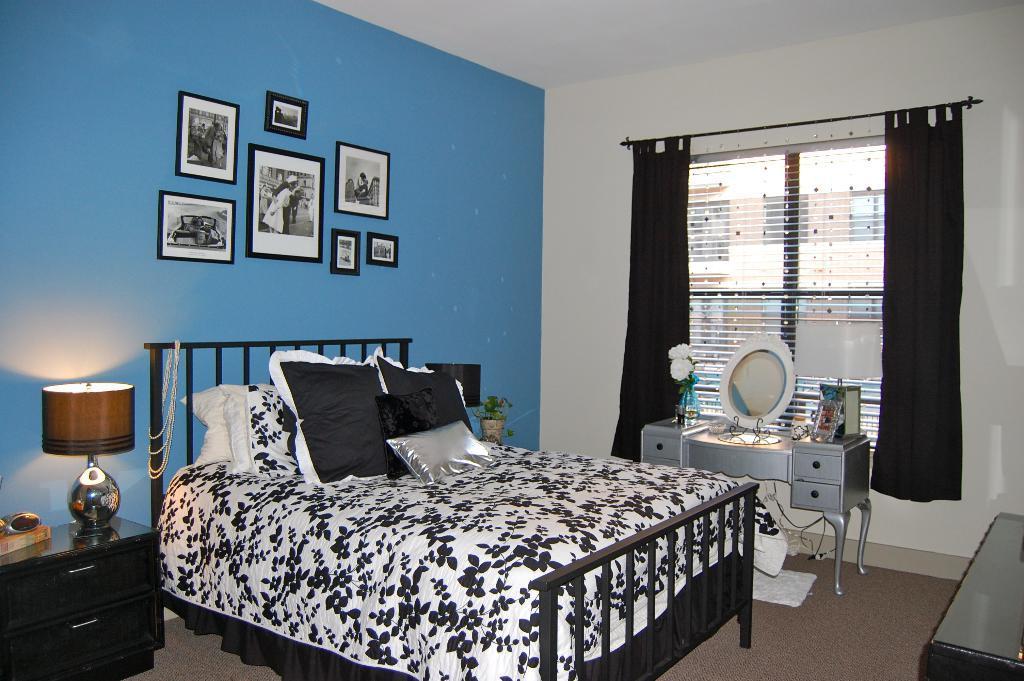Could you give a brief overview of what you see in this image? In this image we can see an inner view of a bedroom containing a bed with some pillows and a lamp on a cupboard. On the right side we can see a table containing a mirror, flower pot and a photo frame on it. We can also see a curtain to a window. On the backside we can see a pot with a plant and some photo frames to a wall. 